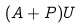<formula> <loc_0><loc_0><loc_500><loc_500>( A + P ) U</formula> 